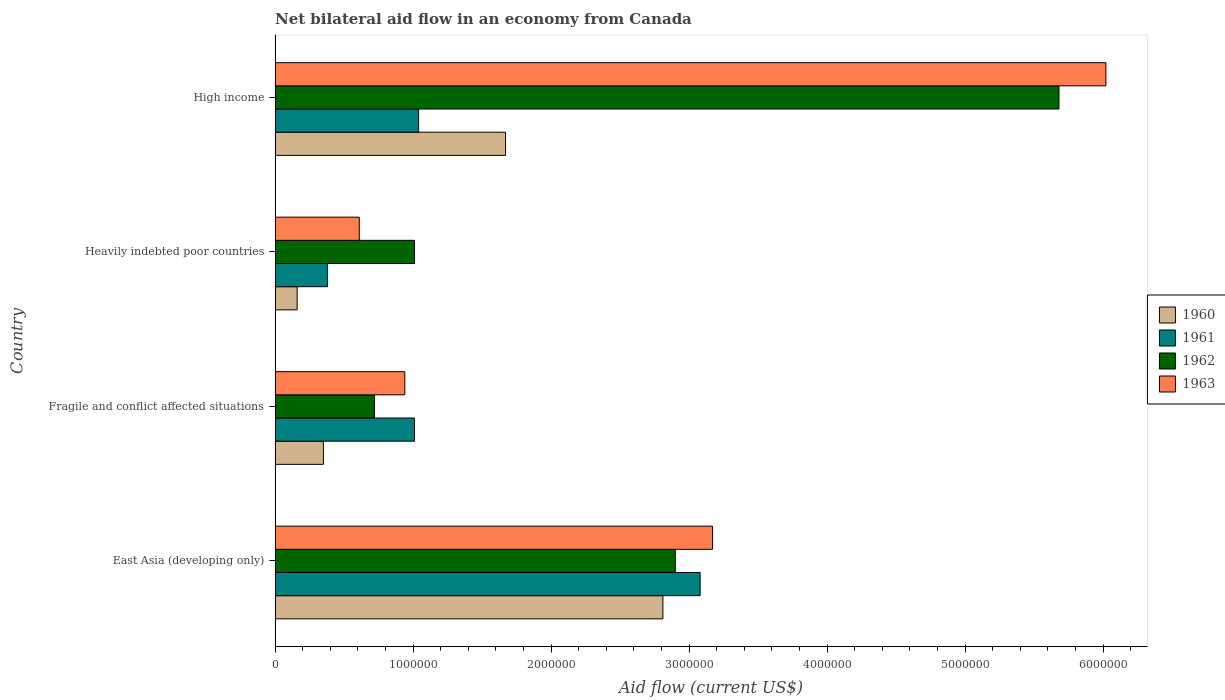How many bars are there on the 1st tick from the top?
Offer a terse response. 4. How many bars are there on the 2nd tick from the bottom?
Your answer should be very brief. 4. What is the label of the 2nd group of bars from the top?
Make the answer very short. Heavily indebted poor countries. Across all countries, what is the maximum net bilateral aid flow in 1963?
Provide a succinct answer. 6.02e+06. Across all countries, what is the minimum net bilateral aid flow in 1961?
Your answer should be compact. 3.80e+05. In which country was the net bilateral aid flow in 1962 maximum?
Ensure brevity in your answer.  High income. In which country was the net bilateral aid flow in 1963 minimum?
Your response must be concise. Heavily indebted poor countries. What is the total net bilateral aid flow in 1961 in the graph?
Provide a succinct answer. 5.51e+06. What is the difference between the net bilateral aid flow in 1963 in Heavily indebted poor countries and that in High income?
Give a very brief answer. -5.41e+06. What is the difference between the net bilateral aid flow in 1963 in Heavily indebted poor countries and the net bilateral aid flow in 1961 in Fragile and conflict affected situations?
Your answer should be compact. -4.00e+05. What is the average net bilateral aid flow in 1962 per country?
Ensure brevity in your answer.  2.58e+06. What is the difference between the net bilateral aid flow in 1962 and net bilateral aid flow in 1961 in East Asia (developing only)?
Provide a short and direct response. -1.80e+05. What is the ratio of the net bilateral aid flow in 1960 in East Asia (developing only) to that in Fragile and conflict affected situations?
Provide a short and direct response. 8.03. Is the difference between the net bilateral aid flow in 1962 in East Asia (developing only) and Fragile and conflict affected situations greater than the difference between the net bilateral aid flow in 1961 in East Asia (developing only) and Fragile and conflict affected situations?
Your answer should be compact. Yes. What is the difference between the highest and the second highest net bilateral aid flow in 1961?
Keep it short and to the point. 2.04e+06. What is the difference between the highest and the lowest net bilateral aid flow in 1960?
Offer a terse response. 2.65e+06. In how many countries, is the net bilateral aid flow in 1962 greater than the average net bilateral aid flow in 1962 taken over all countries?
Your response must be concise. 2. Is it the case that in every country, the sum of the net bilateral aid flow in 1963 and net bilateral aid flow in 1962 is greater than the sum of net bilateral aid flow in 1961 and net bilateral aid flow in 1960?
Offer a terse response. No. Is it the case that in every country, the sum of the net bilateral aid flow in 1961 and net bilateral aid flow in 1960 is greater than the net bilateral aid flow in 1962?
Make the answer very short. No. How many bars are there?
Make the answer very short. 16. Are the values on the major ticks of X-axis written in scientific E-notation?
Your response must be concise. No. Does the graph contain grids?
Give a very brief answer. No. How many legend labels are there?
Provide a short and direct response. 4. What is the title of the graph?
Provide a short and direct response. Net bilateral aid flow in an economy from Canada. What is the label or title of the X-axis?
Give a very brief answer. Aid flow (current US$). What is the Aid flow (current US$) in 1960 in East Asia (developing only)?
Your response must be concise. 2.81e+06. What is the Aid flow (current US$) in 1961 in East Asia (developing only)?
Offer a very short reply. 3.08e+06. What is the Aid flow (current US$) in 1962 in East Asia (developing only)?
Give a very brief answer. 2.90e+06. What is the Aid flow (current US$) of 1963 in East Asia (developing only)?
Your response must be concise. 3.17e+06. What is the Aid flow (current US$) of 1961 in Fragile and conflict affected situations?
Your answer should be compact. 1.01e+06. What is the Aid flow (current US$) in 1962 in Fragile and conflict affected situations?
Offer a very short reply. 7.20e+05. What is the Aid flow (current US$) of 1963 in Fragile and conflict affected situations?
Your answer should be very brief. 9.40e+05. What is the Aid flow (current US$) in 1962 in Heavily indebted poor countries?
Make the answer very short. 1.01e+06. What is the Aid flow (current US$) of 1963 in Heavily indebted poor countries?
Give a very brief answer. 6.10e+05. What is the Aid flow (current US$) of 1960 in High income?
Your answer should be very brief. 1.67e+06. What is the Aid flow (current US$) in 1961 in High income?
Provide a succinct answer. 1.04e+06. What is the Aid flow (current US$) of 1962 in High income?
Keep it short and to the point. 5.68e+06. What is the Aid flow (current US$) in 1963 in High income?
Your response must be concise. 6.02e+06. Across all countries, what is the maximum Aid flow (current US$) of 1960?
Offer a very short reply. 2.81e+06. Across all countries, what is the maximum Aid flow (current US$) in 1961?
Give a very brief answer. 3.08e+06. Across all countries, what is the maximum Aid flow (current US$) of 1962?
Your answer should be compact. 5.68e+06. Across all countries, what is the maximum Aid flow (current US$) in 1963?
Give a very brief answer. 6.02e+06. Across all countries, what is the minimum Aid flow (current US$) in 1961?
Make the answer very short. 3.80e+05. Across all countries, what is the minimum Aid flow (current US$) of 1962?
Give a very brief answer. 7.20e+05. Across all countries, what is the minimum Aid flow (current US$) of 1963?
Give a very brief answer. 6.10e+05. What is the total Aid flow (current US$) in 1960 in the graph?
Make the answer very short. 4.99e+06. What is the total Aid flow (current US$) in 1961 in the graph?
Provide a succinct answer. 5.51e+06. What is the total Aid flow (current US$) of 1962 in the graph?
Ensure brevity in your answer.  1.03e+07. What is the total Aid flow (current US$) in 1963 in the graph?
Make the answer very short. 1.07e+07. What is the difference between the Aid flow (current US$) in 1960 in East Asia (developing only) and that in Fragile and conflict affected situations?
Keep it short and to the point. 2.46e+06. What is the difference between the Aid flow (current US$) in 1961 in East Asia (developing only) and that in Fragile and conflict affected situations?
Your answer should be compact. 2.07e+06. What is the difference between the Aid flow (current US$) in 1962 in East Asia (developing only) and that in Fragile and conflict affected situations?
Provide a short and direct response. 2.18e+06. What is the difference between the Aid flow (current US$) of 1963 in East Asia (developing only) and that in Fragile and conflict affected situations?
Provide a succinct answer. 2.23e+06. What is the difference between the Aid flow (current US$) of 1960 in East Asia (developing only) and that in Heavily indebted poor countries?
Offer a very short reply. 2.65e+06. What is the difference between the Aid flow (current US$) in 1961 in East Asia (developing only) and that in Heavily indebted poor countries?
Your answer should be compact. 2.70e+06. What is the difference between the Aid flow (current US$) of 1962 in East Asia (developing only) and that in Heavily indebted poor countries?
Give a very brief answer. 1.89e+06. What is the difference between the Aid flow (current US$) of 1963 in East Asia (developing only) and that in Heavily indebted poor countries?
Provide a succinct answer. 2.56e+06. What is the difference between the Aid flow (current US$) in 1960 in East Asia (developing only) and that in High income?
Your answer should be very brief. 1.14e+06. What is the difference between the Aid flow (current US$) of 1961 in East Asia (developing only) and that in High income?
Provide a succinct answer. 2.04e+06. What is the difference between the Aid flow (current US$) in 1962 in East Asia (developing only) and that in High income?
Offer a terse response. -2.78e+06. What is the difference between the Aid flow (current US$) in 1963 in East Asia (developing only) and that in High income?
Offer a very short reply. -2.85e+06. What is the difference between the Aid flow (current US$) of 1960 in Fragile and conflict affected situations and that in Heavily indebted poor countries?
Give a very brief answer. 1.90e+05. What is the difference between the Aid flow (current US$) in 1961 in Fragile and conflict affected situations and that in Heavily indebted poor countries?
Your answer should be compact. 6.30e+05. What is the difference between the Aid flow (current US$) in 1962 in Fragile and conflict affected situations and that in Heavily indebted poor countries?
Offer a very short reply. -2.90e+05. What is the difference between the Aid flow (current US$) in 1963 in Fragile and conflict affected situations and that in Heavily indebted poor countries?
Offer a terse response. 3.30e+05. What is the difference between the Aid flow (current US$) in 1960 in Fragile and conflict affected situations and that in High income?
Make the answer very short. -1.32e+06. What is the difference between the Aid flow (current US$) of 1962 in Fragile and conflict affected situations and that in High income?
Ensure brevity in your answer.  -4.96e+06. What is the difference between the Aid flow (current US$) in 1963 in Fragile and conflict affected situations and that in High income?
Your response must be concise. -5.08e+06. What is the difference between the Aid flow (current US$) in 1960 in Heavily indebted poor countries and that in High income?
Keep it short and to the point. -1.51e+06. What is the difference between the Aid flow (current US$) of 1961 in Heavily indebted poor countries and that in High income?
Your answer should be compact. -6.60e+05. What is the difference between the Aid flow (current US$) of 1962 in Heavily indebted poor countries and that in High income?
Provide a short and direct response. -4.67e+06. What is the difference between the Aid flow (current US$) of 1963 in Heavily indebted poor countries and that in High income?
Your response must be concise. -5.41e+06. What is the difference between the Aid flow (current US$) of 1960 in East Asia (developing only) and the Aid flow (current US$) of 1961 in Fragile and conflict affected situations?
Ensure brevity in your answer.  1.80e+06. What is the difference between the Aid flow (current US$) of 1960 in East Asia (developing only) and the Aid flow (current US$) of 1962 in Fragile and conflict affected situations?
Give a very brief answer. 2.09e+06. What is the difference between the Aid flow (current US$) in 1960 in East Asia (developing only) and the Aid flow (current US$) in 1963 in Fragile and conflict affected situations?
Ensure brevity in your answer.  1.87e+06. What is the difference between the Aid flow (current US$) in 1961 in East Asia (developing only) and the Aid flow (current US$) in 1962 in Fragile and conflict affected situations?
Provide a short and direct response. 2.36e+06. What is the difference between the Aid flow (current US$) in 1961 in East Asia (developing only) and the Aid flow (current US$) in 1963 in Fragile and conflict affected situations?
Provide a succinct answer. 2.14e+06. What is the difference between the Aid flow (current US$) of 1962 in East Asia (developing only) and the Aid flow (current US$) of 1963 in Fragile and conflict affected situations?
Offer a very short reply. 1.96e+06. What is the difference between the Aid flow (current US$) in 1960 in East Asia (developing only) and the Aid flow (current US$) in 1961 in Heavily indebted poor countries?
Your answer should be compact. 2.43e+06. What is the difference between the Aid flow (current US$) in 1960 in East Asia (developing only) and the Aid flow (current US$) in 1962 in Heavily indebted poor countries?
Your answer should be very brief. 1.80e+06. What is the difference between the Aid flow (current US$) in 1960 in East Asia (developing only) and the Aid flow (current US$) in 1963 in Heavily indebted poor countries?
Your response must be concise. 2.20e+06. What is the difference between the Aid flow (current US$) in 1961 in East Asia (developing only) and the Aid flow (current US$) in 1962 in Heavily indebted poor countries?
Your answer should be very brief. 2.07e+06. What is the difference between the Aid flow (current US$) in 1961 in East Asia (developing only) and the Aid flow (current US$) in 1963 in Heavily indebted poor countries?
Provide a short and direct response. 2.47e+06. What is the difference between the Aid flow (current US$) of 1962 in East Asia (developing only) and the Aid flow (current US$) of 1963 in Heavily indebted poor countries?
Keep it short and to the point. 2.29e+06. What is the difference between the Aid flow (current US$) in 1960 in East Asia (developing only) and the Aid flow (current US$) in 1961 in High income?
Your answer should be compact. 1.77e+06. What is the difference between the Aid flow (current US$) of 1960 in East Asia (developing only) and the Aid flow (current US$) of 1962 in High income?
Provide a short and direct response. -2.87e+06. What is the difference between the Aid flow (current US$) of 1960 in East Asia (developing only) and the Aid flow (current US$) of 1963 in High income?
Ensure brevity in your answer.  -3.21e+06. What is the difference between the Aid flow (current US$) of 1961 in East Asia (developing only) and the Aid flow (current US$) of 1962 in High income?
Provide a short and direct response. -2.60e+06. What is the difference between the Aid flow (current US$) of 1961 in East Asia (developing only) and the Aid flow (current US$) of 1963 in High income?
Give a very brief answer. -2.94e+06. What is the difference between the Aid flow (current US$) of 1962 in East Asia (developing only) and the Aid flow (current US$) of 1963 in High income?
Ensure brevity in your answer.  -3.12e+06. What is the difference between the Aid flow (current US$) of 1960 in Fragile and conflict affected situations and the Aid flow (current US$) of 1962 in Heavily indebted poor countries?
Offer a very short reply. -6.60e+05. What is the difference between the Aid flow (current US$) in 1960 in Fragile and conflict affected situations and the Aid flow (current US$) in 1963 in Heavily indebted poor countries?
Provide a short and direct response. -2.60e+05. What is the difference between the Aid flow (current US$) of 1960 in Fragile and conflict affected situations and the Aid flow (current US$) of 1961 in High income?
Keep it short and to the point. -6.90e+05. What is the difference between the Aid flow (current US$) of 1960 in Fragile and conflict affected situations and the Aid flow (current US$) of 1962 in High income?
Keep it short and to the point. -5.33e+06. What is the difference between the Aid flow (current US$) of 1960 in Fragile and conflict affected situations and the Aid flow (current US$) of 1963 in High income?
Your response must be concise. -5.67e+06. What is the difference between the Aid flow (current US$) of 1961 in Fragile and conflict affected situations and the Aid flow (current US$) of 1962 in High income?
Your answer should be very brief. -4.67e+06. What is the difference between the Aid flow (current US$) in 1961 in Fragile and conflict affected situations and the Aid flow (current US$) in 1963 in High income?
Ensure brevity in your answer.  -5.01e+06. What is the difference between the Aid flow (current US$) of 1962 in Fragile and conflict affected situations and the Aid flow (current US$) of 1963 in High income?
Provide a succinct answer. -5.30e+06. What is the difference between the Aid flow (current US$) in 1960 in Heavily indebted poor countries and the Aid flow (current US$) in 1961 in High income?
Your answer should be very brief. -8.80e+05. What is the difference between the Aid flow (current US$) of 1960 in Heavily indebted poor countries and the Aid flow (current US$) of 1962 in High income?
Give a very brief answer. -5.52e+06. What is the difference between the Aid flow (current US$) in 1960 in Heavily indebted poor countries and the Aid flow (current US$) in 1963 in High income?
Make the answer very short. -5.86e+06. What is the difference between the Aid flow (current US$) in 1961 in Heavily indebted poor countries and the Aid flow (current US$) in 1962 in High income?
Provide a short and direct response. -5.30e+06. What is the difference between the Aid flow (current US$) of 1961 in Heavily indebted poor countries and the Aid flow (current US$) of 1963 in High income?
Your answer should be very brief. -5.64e+06. What is the difference between the Aid flow (current US$) in 1962 in Heavily indebted poor countries and the Aid flow (current US$) in 1963 in High income?
Offer a terse response. -5.01e+06. What is the average Aid flow (current US$) of 1960 per country?
Offer a terse response. 1.25e+06. What is the average Aid flow (current US$) of 1961 per country?
Your response must be concise. 1.38e+06. What is the average Aid flow (current US$) of 1962 per country?
Make the answer very short. 2.58e+06. What is the average Aid flow (current US$) in 1963 per country?
Make the answer very short. 2.68e+06. What is the difference between the Aid flow (current US$) of 1960 and Aid flow (current US$) of 1963 in East Asia (developing only)?
Your answer should be compact. -3.60e+05. What is the difference between the Aid flow (current US$) in 1961 and Aid flow (current US$) in 1963 in East Asia (developing only)?
Provide a short and direct response. -9.00e+04. What is the difference between the Aid flow (current US$) in 1962 and Aid flow (current US$) in 1963 in East Asia (developing only)?
Your answer should be compact. -2.70e+05. What is the difference between the Aid flow (current US$) of 1960 and Aid flow (current US$) of 1961 in Fragile and conflict affected situations?
Offer a terse response. -6.60e+05. What is the difference between the Aid flow (current US$) of 1960 and Aid flow (current US$) of 1962 in Fragile and conflict affected situations?
Offer a terse response. -3.70e+05. What is the difference between the Aid flow (current US$) in 1960 and Aid flow (current US$) in 1963 in Fragile and conflict affected situations?
Provide a succinct answer. -5.90e+05. What is the difference between the Aid flow (current US$) of 1961 and Aid flow (current US$) of 1963 in Fragile and conflict affected situations?
Offer a very short reply. 7.00e+04. What is the difference between the Aid flow (current US$) in 1960 and Aid flow (current US$) in 1961 in Heavily indebted poor countries?
Make the answer very short. -2.20e+05. What is the difference between the Aid flow (current US$) of 1960 and Aid flow (current US$) of 1962 in Heavily indebted poor countries?
Your answer should be compact. -8.50e+05. What is the difference between the Aid flow (current US$) in 1960 and Aid flow (current US$) in 1963 in Heavily indebted poor countries?
Keep it short and to the point. -4.50e+05. What is the difference between the Aid flow (current US$) in 1961 and Aid flow (current US$) in 1962 in Heavily indebted poor countries?
Your answer should be very brief. -6.30e+05. What is the difference between the Aid flow (current US$) in 1961 and Aid flow (current US$) in 1963 in Heavily indebted poor countries?
Keep it short and to the point. -2.30e+05. What is the difference between the Aid flow (current US$) of 1962 and Aid flow (current US$) of 1963 in Heavily indebted poor countries?
Make the answer very short. 4.00e+05. What is the difference between the Aid flow (current US$) of 1960 and Aid flow (current US$) of 1961 in High income?
Ensure brevity in your answer.  6.30e+05. What is the difference between the Aid flow (current US$) in 1960 and Aid flow (current US$) in 1962 in High income?
Ensure brevity in your answer.  -4.01e+06. What is the difference between the Aid flow (current US$) in 1960 and Aid flow (current US$) in 1963 in High income?
Ensure brevity in your answer.  -4.35e+06. What is the difference between the Aid flow (current US$) of 1961 and Aid flow (current US$) of 1962 in High income?
Make the answer very short. -4.64e+06. What is the difference between the Aid flow (current US$) of 1961 and Aid flow (current US$) of 1963 in High income?
Your answer should be compact. -4.98e+06. What is the ratio of the Aid flow (current US$) in 1960 in East Asia (developing only) to that in Fragile and conflict affected situations?
Provide a succinct answer. 8.03. What is the ratio of the Aid flow (current US$) in 1961 in East Asia (developing only) to that in Fragile and conflict affected situations?
Ensure brevity in your answer.  3.05. What is the ratio of the Aid flow (current US$) in 1962 in East Asia (developing only) to that in Fragile and conflict affected situations?
Provide a succinct answer. 4.03. What is the ratio of the Aid flow (current US$) of 1963 in East Asia (developing only) to that in Fragile and conflict affected situations?
Your response must be concise. 3.37. What is the ratio of the Aid flow (current US$) of 1960 in East Asia (developing only) to that in Heavily indebted poor countries?
Give a very brief answer. 17.56. What is the ratio of the Aid flow (current US$) of 1961 in East Asia (developing only) to that in Heavily indebted poor countries?
Offer a terse response. 8.11. What is the ratio of the Aid flow (current US$) in 1962 in East Asia (developing only) to that in Heavily indebted poor countries?
Ensure brevity in your answer.  2.87. What is the ratio of the Aid flow (current US$) in 1963 in East Asia (developing only) to that in Heavily indebted poor countries?
Offer a terse response. 5.2. What is the ratio of the Aid flow (current US$) of 1960 in East Asia (developing only) to that in High income?
Make the answer very short. 1.68. What is the ratio of the Aid flow (current US$) of 1961 in East Asia (developing only) to that in High income?
Give a very brief answer. 2.96. What is the ratio of the Aid flow (current US$) in 1962 in East Asia (developing only) to that in High income?
Provide a short and direct response. 0.51. What is the ratio of the Aid flow (current US$) in 1963 in East Asia (developing only) to that in High income?
Keep it short and to the point. 0.53. What is the ratio of the Aid flow (current US$) of 1960 in Fragile and conflict affected situations to that in Heavily indebted poor countries?
Give a very brief answer. 2.19. What is the ratio of the Aid flow (current US$) of 1961 in Fragile and conflict affected situations to that in Heavily indebted poor countries?
Ensure brevity in your answer.  2.66. What is the ratio of the Aid flow (current US$) of 1962 in Fragile and conflict affected situations to that in Heavily indebted poor countries?
Make the answer very short. 0.71. What is the ratio of the Aid flow (current US$) of 1963 in Fragile and conflict affected situations to that in Heavily indebted poor countries?
Give a very brief answer. 1.54. What is the ratio of the Aid flow (current US$) in 1960 in Fragile and conflict affected situations to that in High income?
Make the answer very short. 0.21. What is the ratio of the Aid flow (current US$) of 1961 in Fragile and conflict affected situations to that in High income?
Keep it short and to the point. 0.97. What is the ratio of the Aid flow (current US$) of 1962 in Fragile and conflict affected situations to that in High income?
Offer a very short reply. 0.13. What is the ratio of the Aid flow (current US$) of 1963 in Fragile and conflict affected situations to that in High income?
Give a very brief answer. 0.16. What is the ratio of the Aid flow (current US$) of 1960 in Heavily indebted poor countries to that in High income?
Provide a short and direct response. 0.1. What is the ratio of the Aid flow (current US$) in 1961 in Heavily indebted poor countries to that in High income?
Give a very brief answer. 0.37. What is the ratio of the Aid flow (current US$) of 1962 in Heavily indebted poor countries to that in High income?
Offer a very short reply. 0.18. What is the ratio of the Aid flow (current US$) of 1963 in Heavily indebted poor countries to that in High income?
Ensure brevity in your answer.  0.1. What is the difference between the highest and the second highest Aid flow (current US$) of 1960?
Keep it short and to the point. 1.14e+06. What is the difference between the highest and the second highest Aid flow (current US$) of 1961?
Ensure brevity in your answer.  2.04e+06. What is the difference between the highest and the second highest Aid flow (current US$) in 1962?
Keep it short and to the point. 2.78e+06. What is the difference between the highest and the second highest Aid flow (current US$) in 1963?
Keep it short and to the point. 2.85e+06. What is the difference between the highest and the lowest Aid flow (current US$) of 1960?
Give a very brief answer. 2.65e+06. What is the difference between the highest and the lowest Aid flow (current US$) of 1961?
Keep it short and to the point. 2.70e+06. What is the difference between the highest and the lowest Aid flow (current US$) of 1962?
Keep it short and to the point. 4.96e+06. What is the difference between the highest and the lowest Aid flow (current US$) of 1963?
Give a very brief answer. 5.41e+06. 